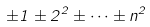Convert formula to latex. <formula><loc_0><loc_0><loc_500><loc_500>\pm 1 \pm 2 ^ { 2 } \pm \dots \pm n ^ { 2 }</formula> 